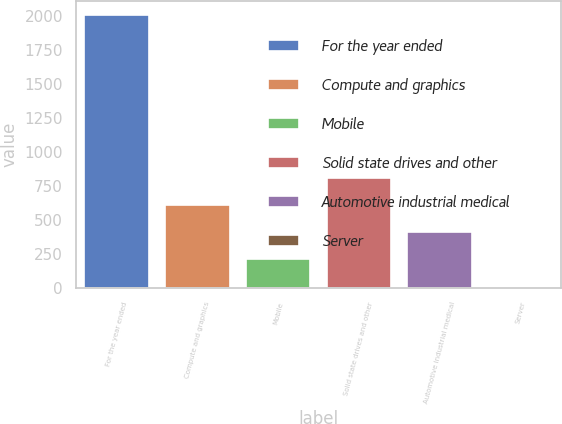Convert chart. <chart><loc_0><loc_0><loc_500><loc_500><bar_chart><fcel>For the year ended<fcel>Compute and graphics<fcel>Mobile<fcel>Solid state drives and other<fcel>Automotive industrial medical<fcel>Server<nl><fcel>2013<fcel>610.9<fcel>210.3<fcel>811.2<fcel>410.6<fcel>10<nl></chart> 